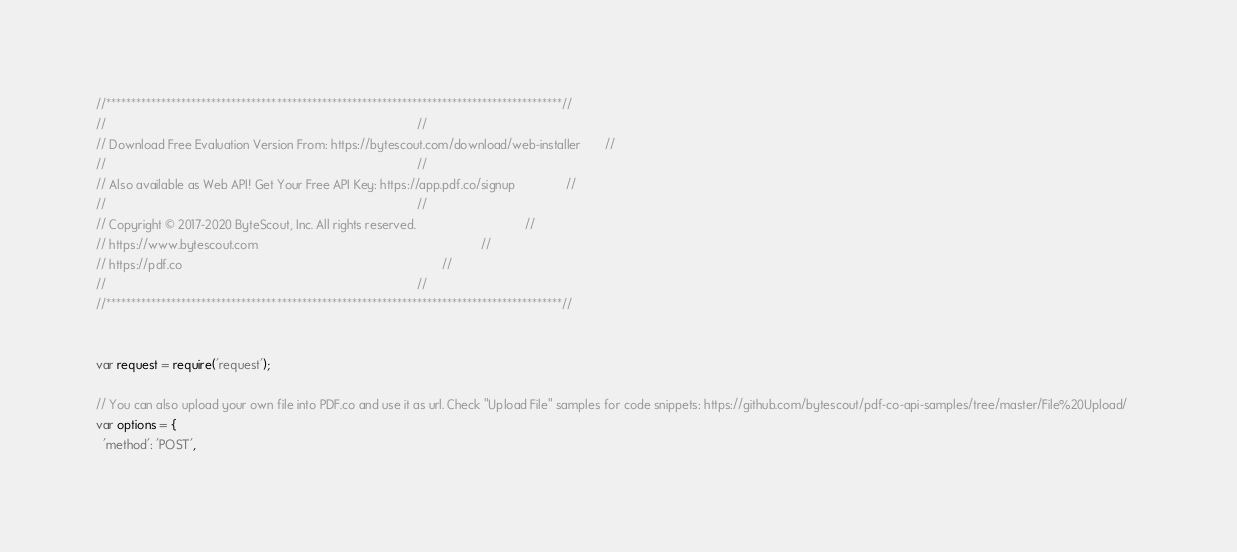Convert code to text. <code><loc_0><loc_0><loc_500><loc_500><_JavaScript_>//*******************************************************************************************//
//                                                                                           //
// Download Free Evaluation Version From: https://bytescout.com/download/web-installer       //
//                                                                                           //
// Also available as Web API! Get Your Free API Key: https://app.pdf.co/signup               //
//                                                                                           //
// Copyright © 2017-2020 ByteScout, Inc. All rights reserved.                                //
// https://www.bytescout.com                                                                 //
// https://pdf.co                                                                            //
//                                                                                           //
//*******************************************************************************************//


var request = require('request');

// You can also upload your own file into PDF.co and use it as url. Check "Upload File" samples for code snippets: https://github.com/bytescout/pdf-co-api-samples/tree/master/File%20Upload/    
var options = {
  'method': 'POST',</code> 